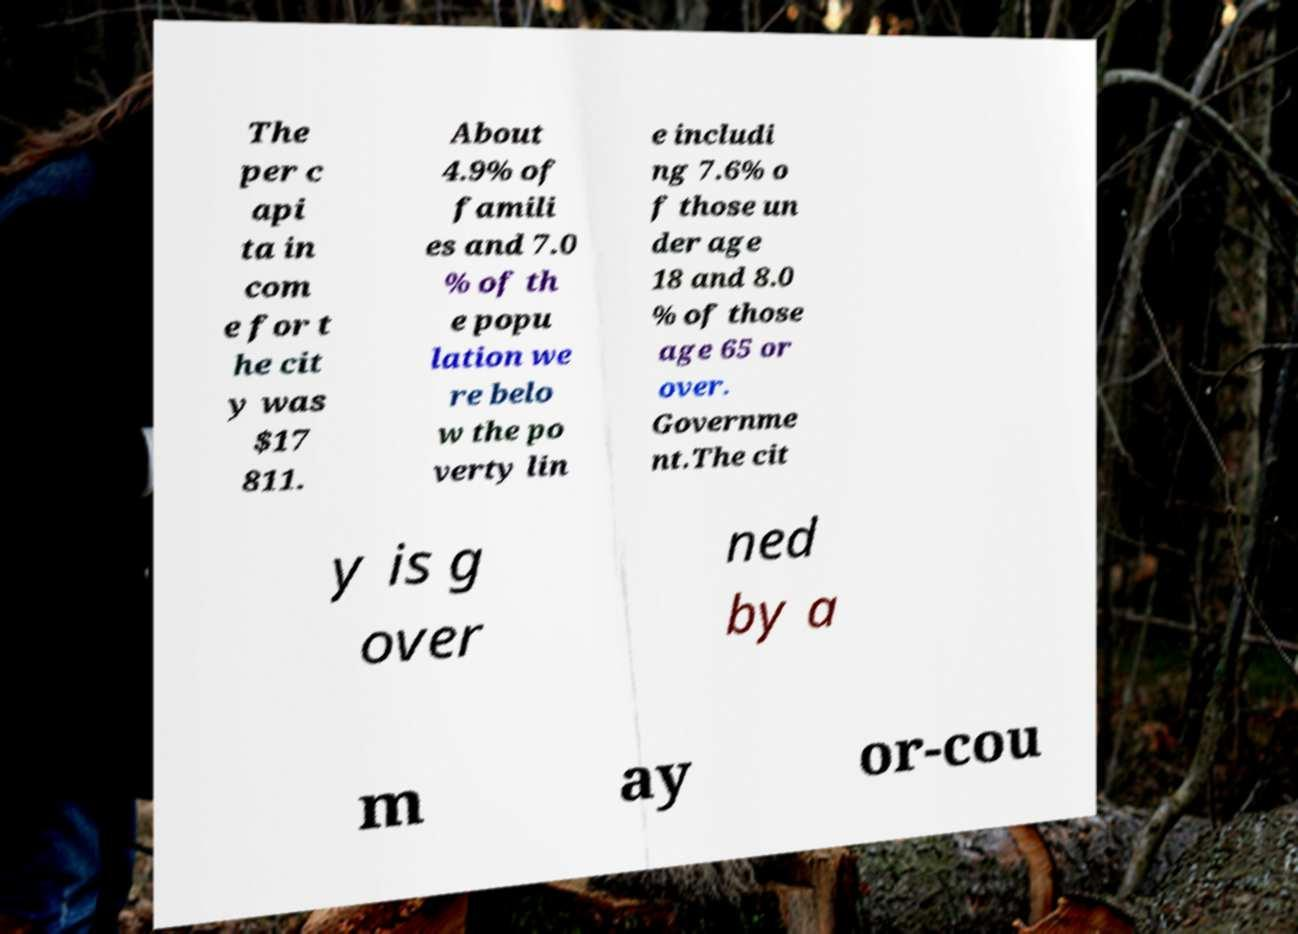Please identify and transcribe the text found in this image. The per c api ta in com e for t he cit y was $17 811. About 4.9% of famili es and 7.0 % of th e popu lation we re belo w the po verty lin e includi ng 7.6% o f those un der age 18 and 8.0 % of those age 65 or over. Governme nt.The cit y is g over ned by a m ay or-cou 